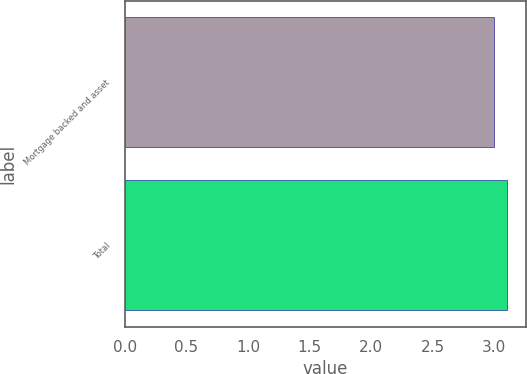<chart> <loc_0><loc_0><loc_500><loc_500><bar_chart><fcel>Mortgage backed and asset<fcel>Total<nl><fcel>3<fcel>3.1<nl></chart> 